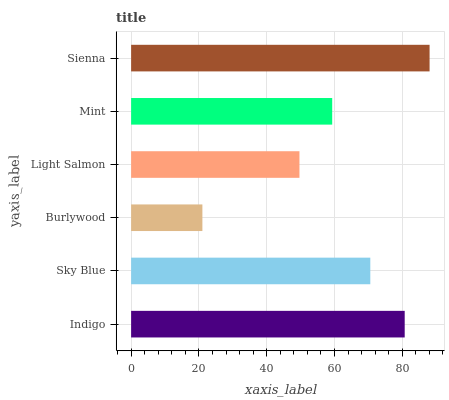Is Burlywood the minimum?
Answer yes or no. Yes. Is Sienna the maximum?
Answer yes or no. Yes. Is Sky Blue the minimum?
Answer yes or no. No. Is Sky Blue the maximum?
Answer yes or no. No. Is Indigo greater than Sky Blue?
Answer yes or no. Yes. Is Sky Blue less than Indigo?
Answer yes or no. Yes. Is Sky Blue greater than Indigo?
Answer yes or no. No. Is Indigo less than Sky Blue?
Answer yes or no. No. Is Sky Blue the high median?
Answer yes or no. Yes. Is Mint the low median?
Answer yes or no. Yes. Is Sienna the high median?
Answer yes or no. No. Is Burlywood the low median?
Answer yes or no. No. 